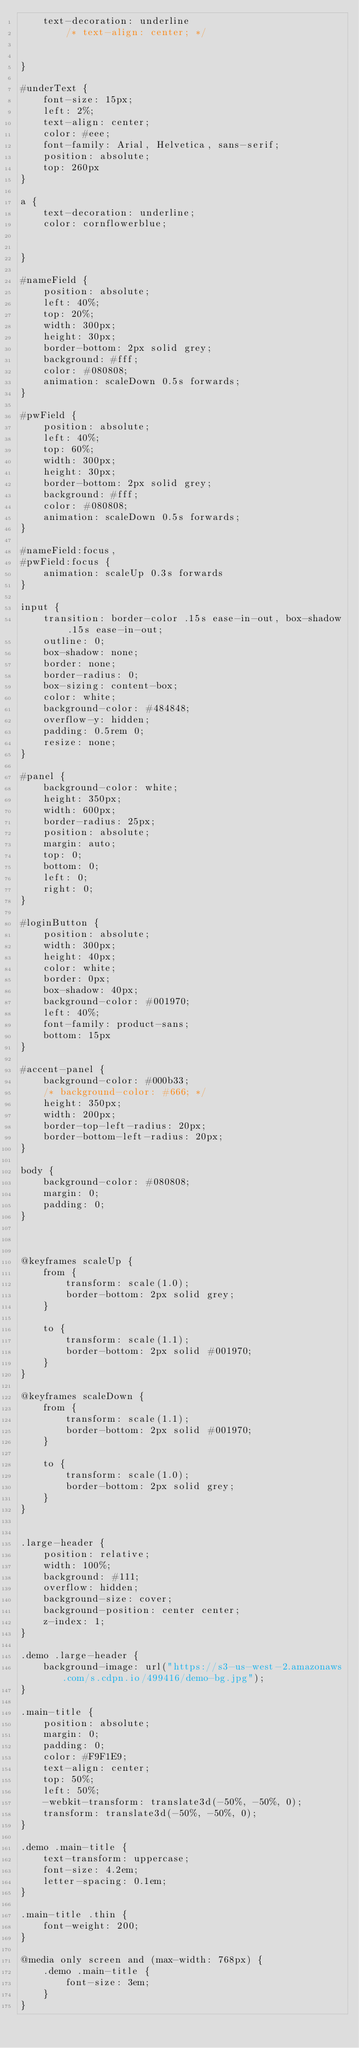Convert code to text. <code><loc_0><loc_0><loc_500><loc_500><_CSS_>    text-decoration: underline
        /* text-align: center; */


}

#underText {
    font-size: 15px;
    left: 2%;
    text-align: center;
    color: #eee;
    font-family: Arial, Helvetica, sans-serif;
    position: absolute;
    top: 260px
}

a {
    text-decoration: underline;
    color: cornflowerblue;


}

#nameField {
    position: absolute;
    left: 40%;
    top: 20%;
    width: 300px;
    height: 30px;
    border-bottom: 2px solid grey;
    background: #fff;
    color: #080808;
    animation: scaleDown 0.5s forwards;
}

#pwField {
    position: absolute;
    left: 40%;
    top: 60%;
    width: 300px;
    height: 30px;
    border-bottom: 2px solid grey;
    background: #fff;
    color: #080808;
    animation: scaleDown 0.5s forwards;
}

#nameField:focus,
#pwField:focus {
    animation: scaleUp 0.3s forwards
}

input {
    transition: border-color .15s ease-in-out, box-shadow .15s ease-in-out;
    outline: 0;
    box-shadow: none;
    border: none;
    border-radius: 0;
    box-sizing: content-box;
    color: white;
    background-color: #484848;
    overflow-y: hidden;
    padding: 0.5rem 0;
    resize: none;
}

#panel {
    background-color: white;
    height: 350px;
    width: 600px;
    border-radius: 25px;
    position: absolute;
    margin: auto;
    top: 0;
    bottom: 0;
    left: 0;
    right: 0;
}

#loginButton {
    position: absolute;
    width: 300px;
    height: 40px;
    color: white;
    border: 0px;
    box-shadow: 40px;
    background-color: #001970;
    left: 40%;
    font-family: product-sans;
    bottom: 15px
}

#accent-panel {
    background-color: #000b33;
    /* background-color: #666; */
    height: 350px;
    width: 200px;
    border-top-left-radius: 20px;
    border-bottom-left-radius: 20px;
}

body {
    background-color: #080808;
    margin: 0;
    padding: 0;
}



@keyframes scaleUp {
    from {
        transform: scale(1.0);
        border-bottom: 2px solid grey;
    }

    to {
        transform: scale(1.1);
        border-bottom: 2px solid #001970;
    }
}

@keyframes scaleDown {
    from {
        transform: scale(1.1);
        border-bottom: 2px solid #001970;
    }

    to {
        transform: scale(1.0);
        border-bottom: 2px solid grey;
    }
}


.large-header {
    position: relative;
    width: 100%;
    background: #111;
    overflow: hidden;
    background-size: cover;
    background-position: center center;
    z-index: 1;
}

.demo .large-header {
    background-image: url("https://s3-us-west-2.amazonaws.com/s.cdpn.io/499416/demo-bg.jpg");
}

.main-title {
    position: absolute;
    margin: 0;
    padding: 0;
    color: #F9F1E9;
    text-align: center;
    top: 50%;
    left: 50%;
    -webkit-transform: translate3d(-50%, -50%, 0);
    transform: translate3d(-50%, -50%, 0);
}

.demo .main-title {
    text-transform: uppercase;
    font-size: 4.2em;
    letter-spacing: 0.1em;
}

.main-title .thin {
    font-weight: 200;
}

@media only screen and (max-width: 768px) {
    .demo .main-title {
        font-size: 3em;
    }
}</code> 